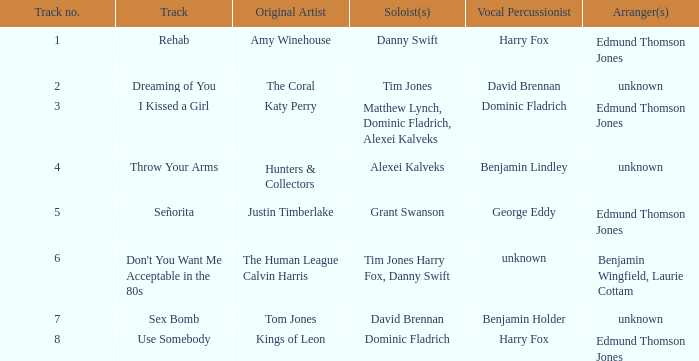Who is the arranger for "I KIssed a Girl"? Edmund Thomson Jones. 